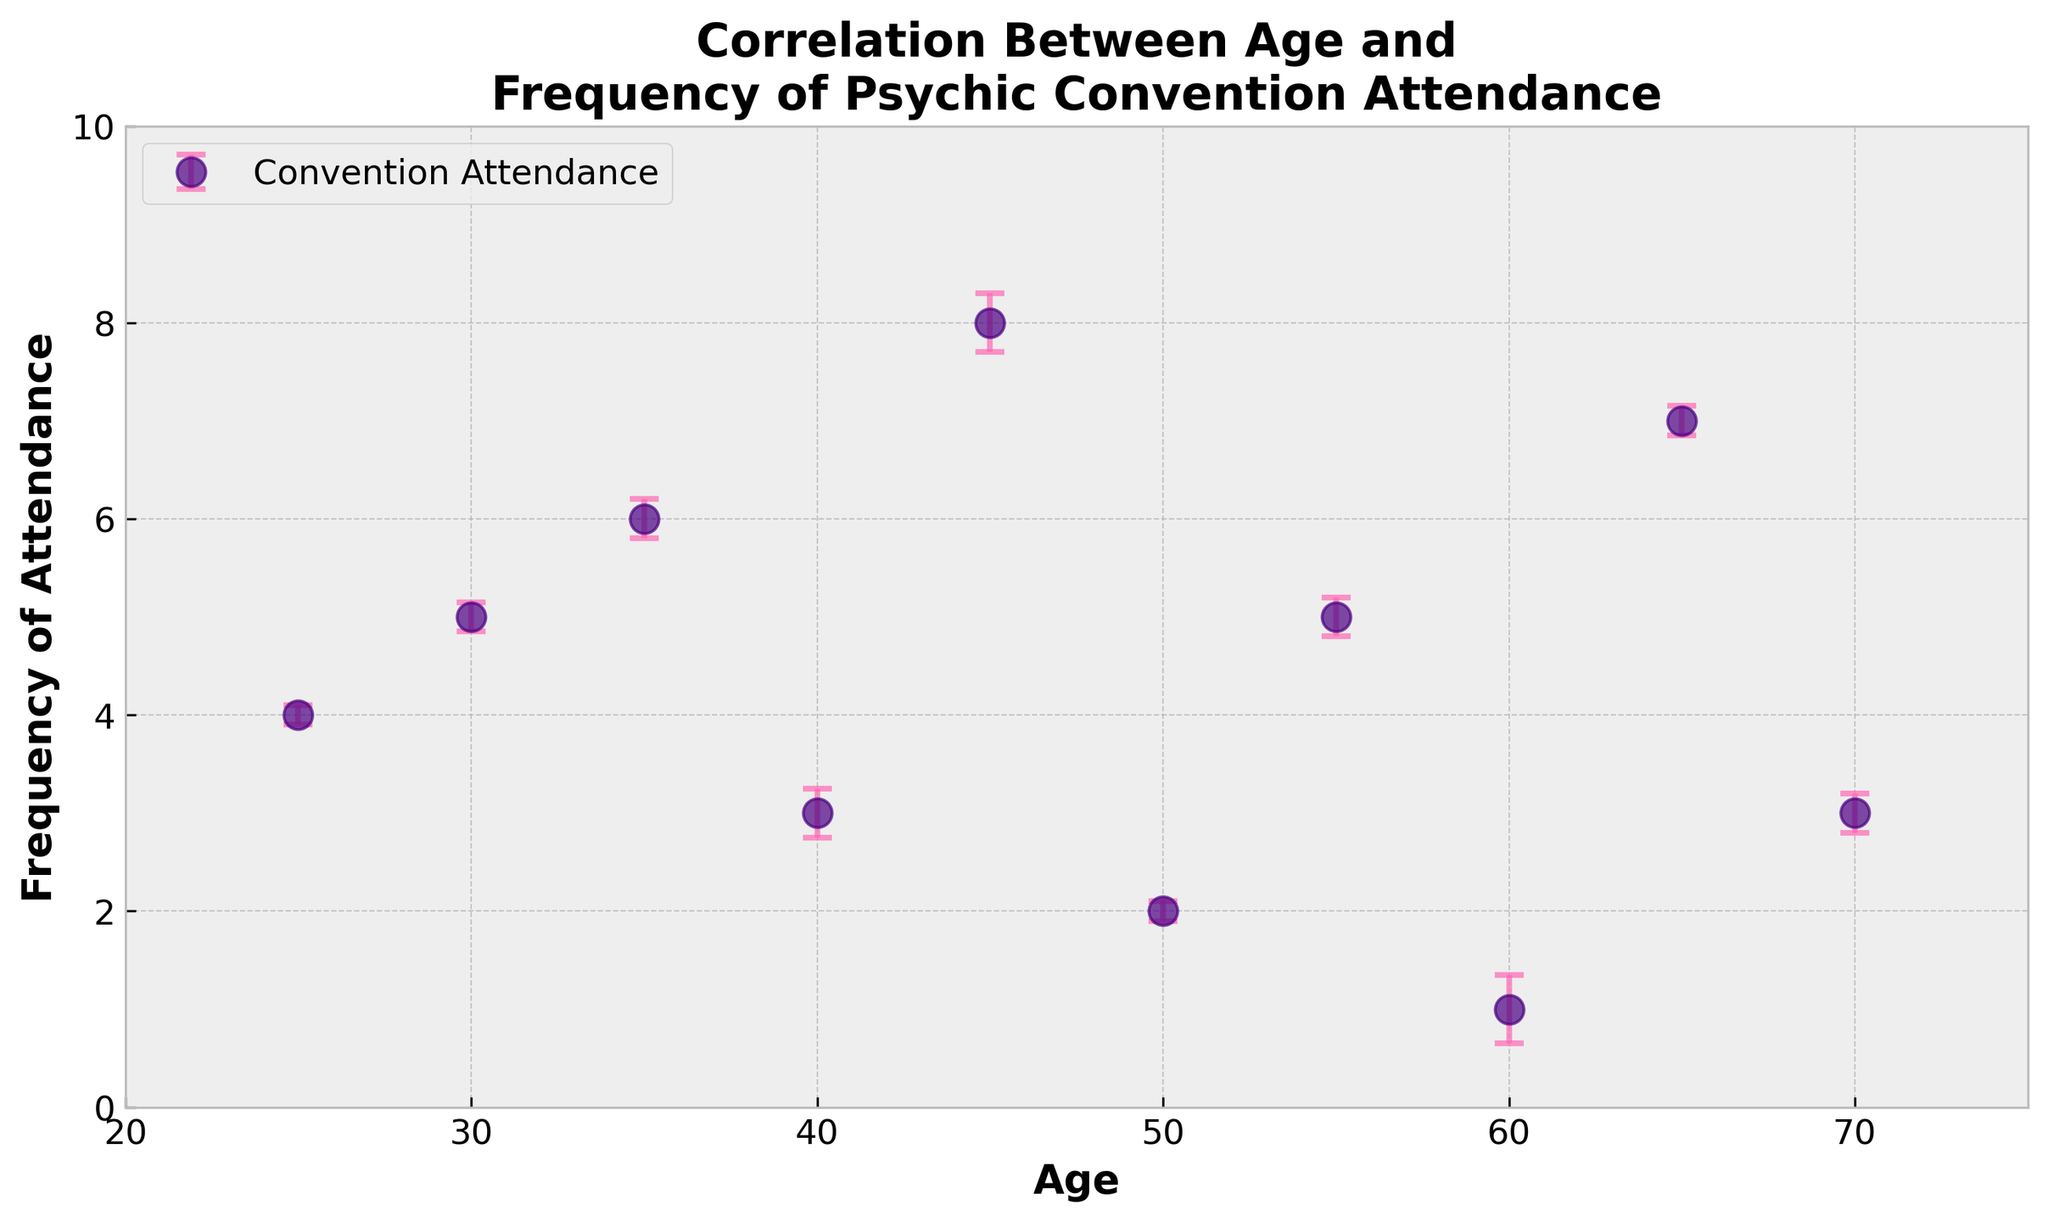What's the title of the scatter plot? The title can be directly read from the top of the scatter plot.
Answer: Correlation Between Age and Frequency of Psychic Convention Attendance What is the x-axis label? The x-axis label is given below the horizontal axis of the scatter plot.
Answer: Age How many data points are there in the plot? Each point represents an individual data pair of age and frequency of attendance, distinguishable by circular markers. Count them.
Answer: 10 Which age group has the highest frequency of attendance? From the plot, identify the highest y-value among the data points and check the corresponding x-value (age).
Answer: 45 What is the frequency of attendance for the age group 50? Locate the point where Age is 50 on the x-axis, then trace vertically to find its y-value.
Answer: 2 Which data point has the highest perspective uncertainty? Identify the data point with the longest error bar by comparing the vertical lines around each point.
Answer: Age 60 Compare the frequency of attendance between age 30 and 60. Which is higher? Locate the points for Age 30 and Age 60 on the x-axis and compare their y-values (frequency of attendance).
Answer: 30 Calculate the average frequency of attendance across all age groups. Sum up all frequency values (4+5+6+3+8+2+5+1+7+3) and divide by the number of data points (10).
Answer: 4.4 Is there a trend visible between age and frequency of attendance? Observe the general pattern formed by the data points, if it increases, decreases, or is random.
Answer: No clear trend Between which ages do we see the largest decrease in frequency of attendance? Compare the differences in frequency values between consecutive points to find the largest decrease.
Answer: 35 to 40 